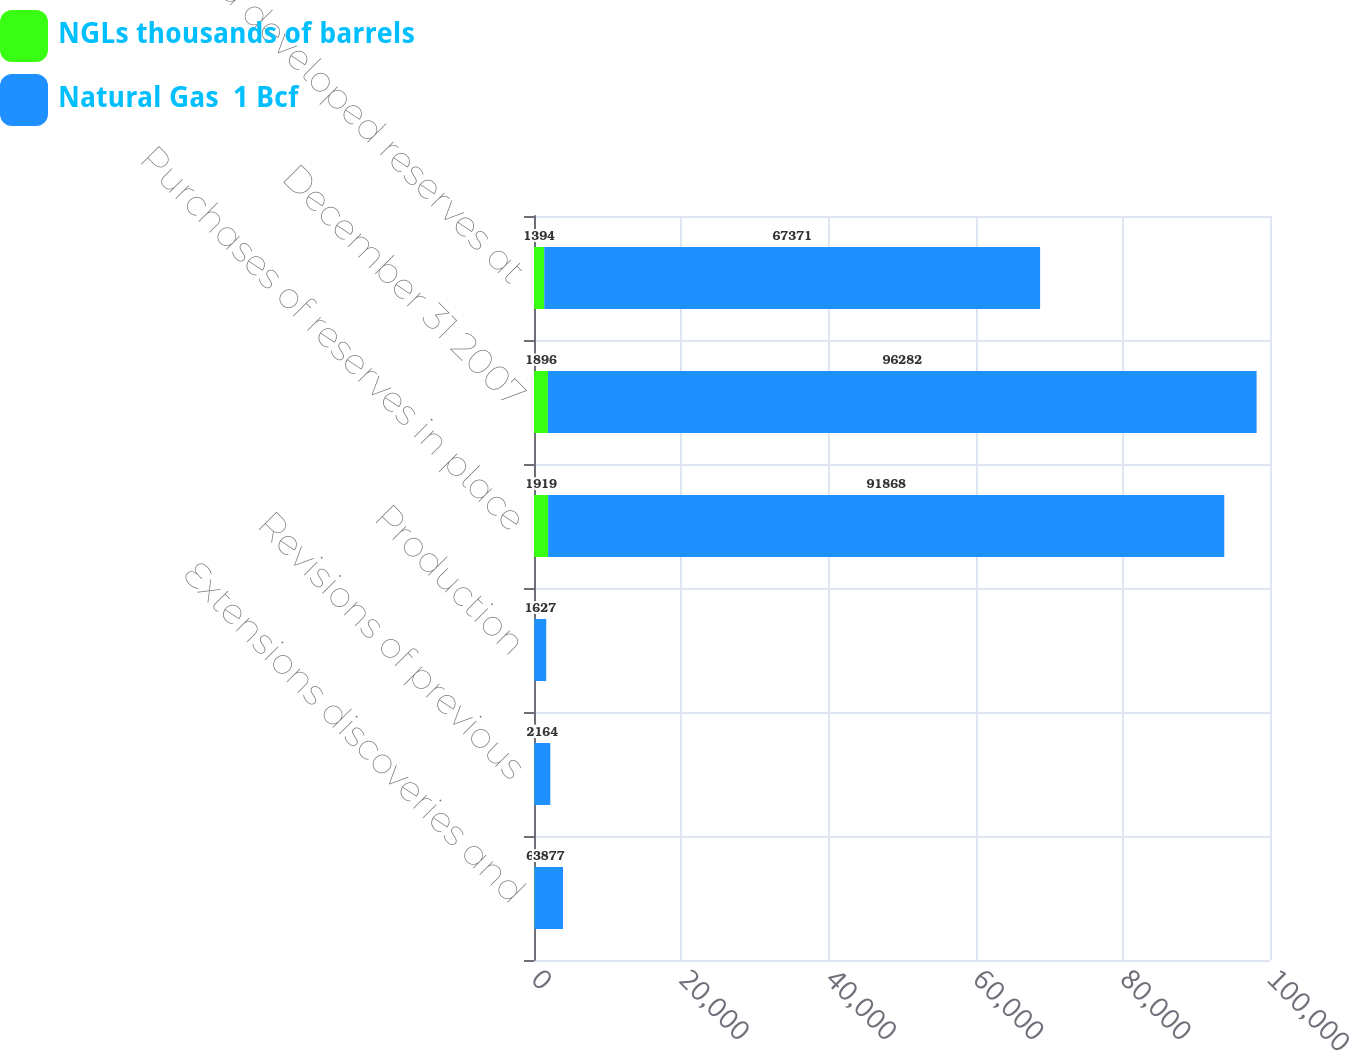Convert chart to OTSL. <chart><loc_0><loc_0><loc_500><loc_500><stacked_bar_chart><ecel><fcel>Extensions discoveries and<fcel>Revisions of previous<fcel>Production<fcel>Purchases of reserves in place<fcel>December 31 2007<fcel>Proved developed reserves at<nl><fcel>NGLs thousands of barrels<fcel>62<fcel>51<fcel>34<fcel>1919<fcel>1896<fcel>1394<nl><fcel>Natural Gas  1 Bcf<fcel>3877<fcel>2164<fcel>1627<fcel>91868<fcel>96282<fcel>67371<nl></chart> 